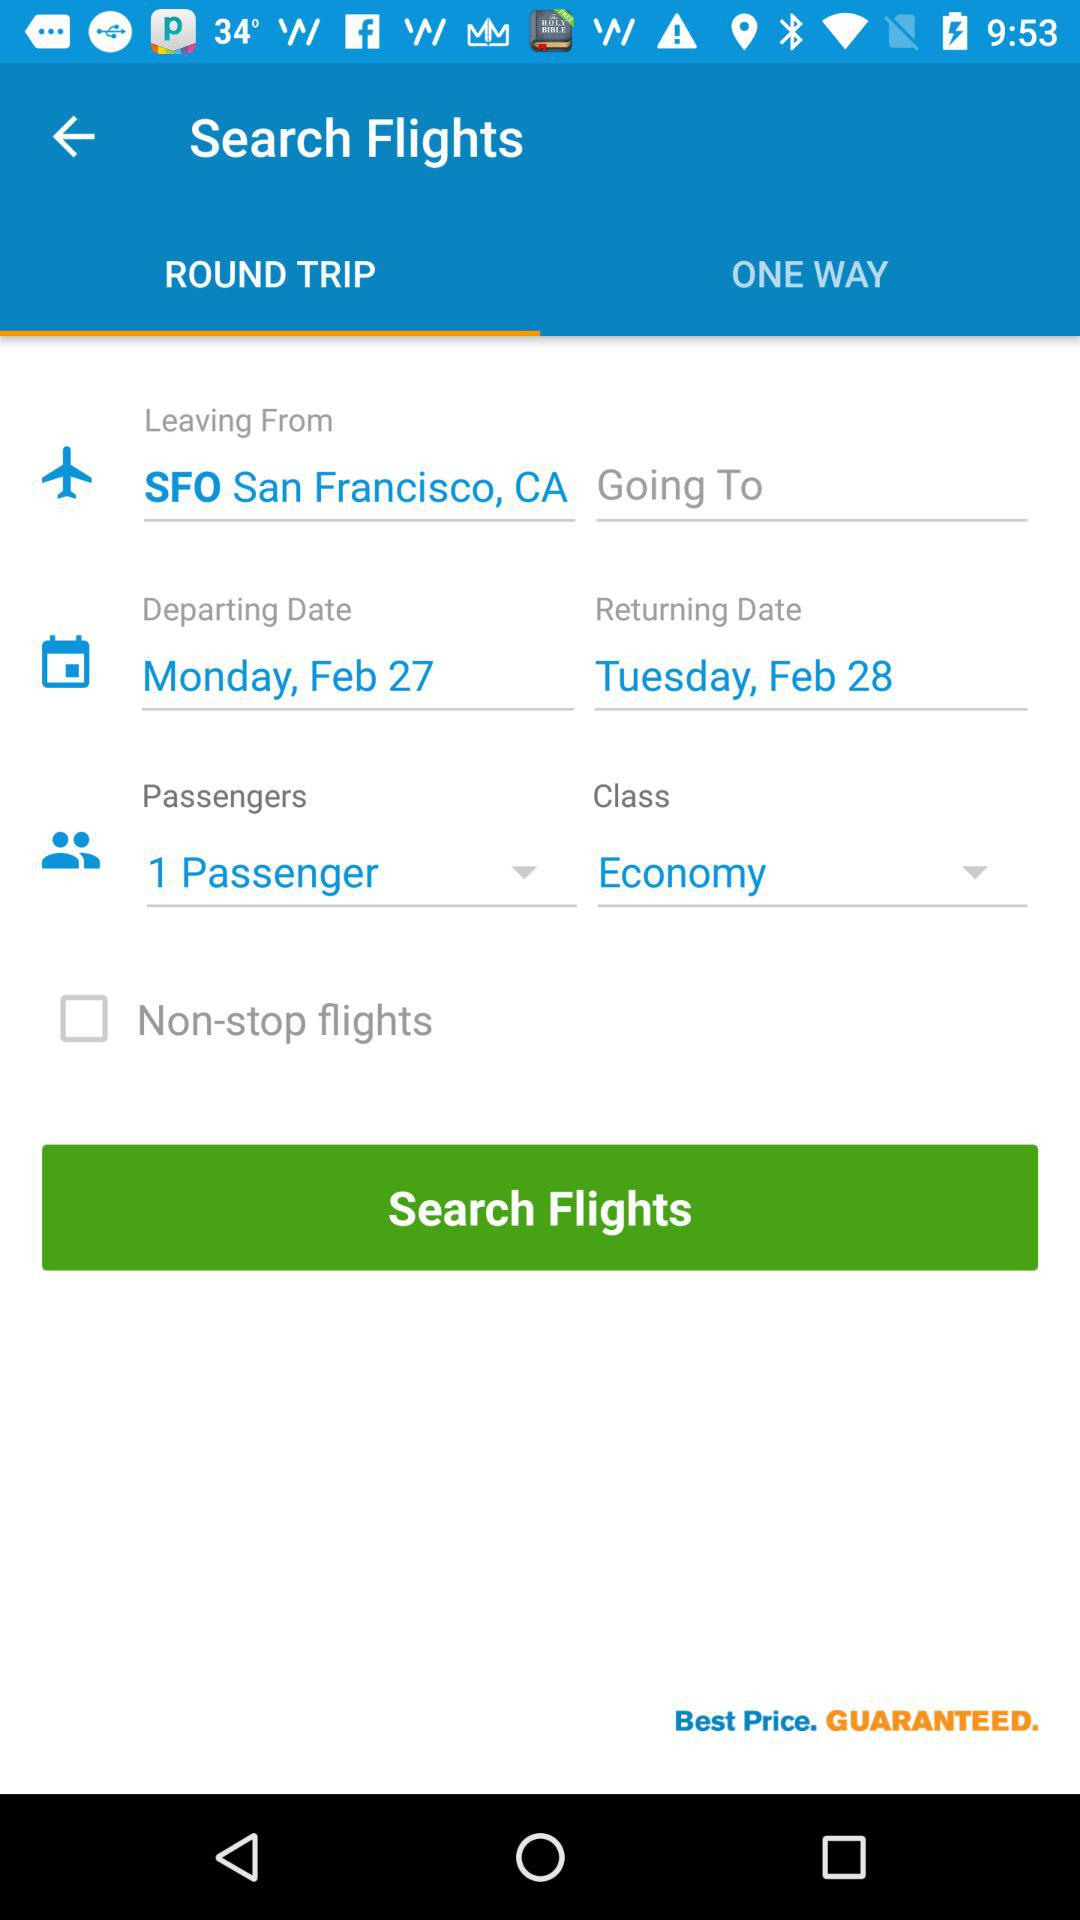What is the mentioned location? The mentioned location is SFO, San Francisco, CA. 